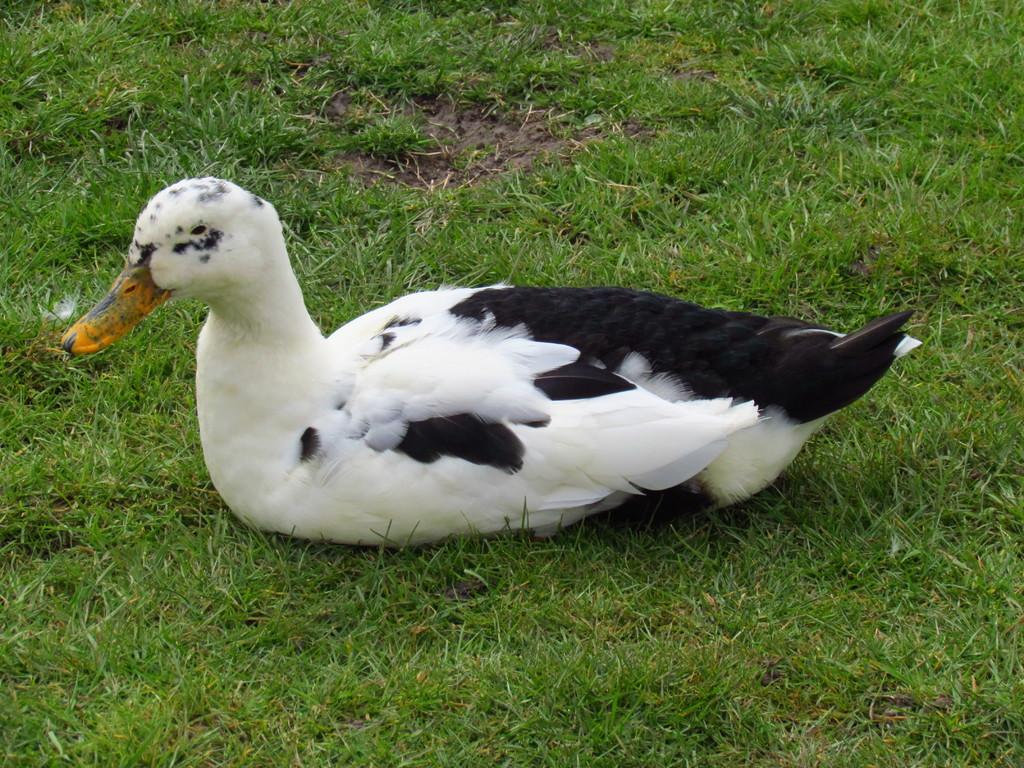What type of animal is present in the image? There is a duck in the image. What colors can be seen on the duck? The duck is white and black in color. Where is the duck located in the image? The duck is sitting in a grass lawn. What type of mask is the duck wearing in the image? There is no mask present on the duck in the image. 